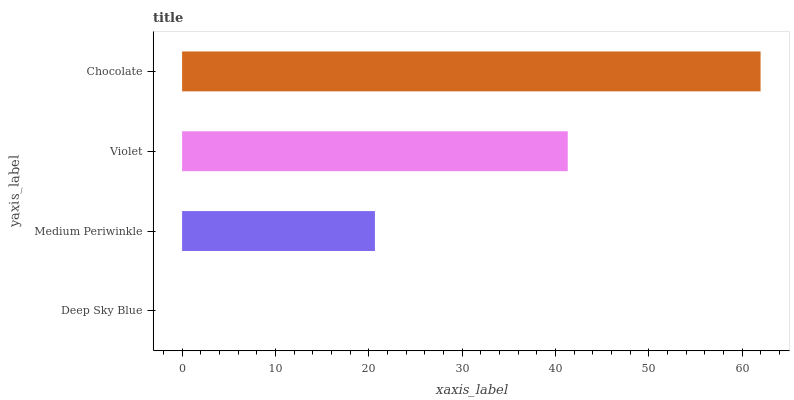Is Deep Sky Blue the minimum?
Answer yes or no. Yes. Is Chocolate the maximum?
Answer yes or no. Yes. Is Medium Periwinkle the minimum?
Answer yes or no. No. Is Medium Periwinkle the maximum?
Answer yes or no. No. Is Medium Periwinkle greater than Deep Sky Blue?
Answer yes or no. Yes. Is Deep Sky Blue less than Medium Periwinkle?
Answer yes or no. Yes. Is Deep Sky Blue greater than Medium Periwinkle?
Answer yes or no. No. Is Medium Periwinkle less than Deep Sky Blue?
Answer yes or no. No. Is Violet the high median?
Answer yes or no. Yes. Is Medium Periwinkle the low median?
Answer yes or no. Yes. Is Chocolate the high median?
Answer yes or no. No. Is Chocolate the low median?
Answer yes or no. No. 